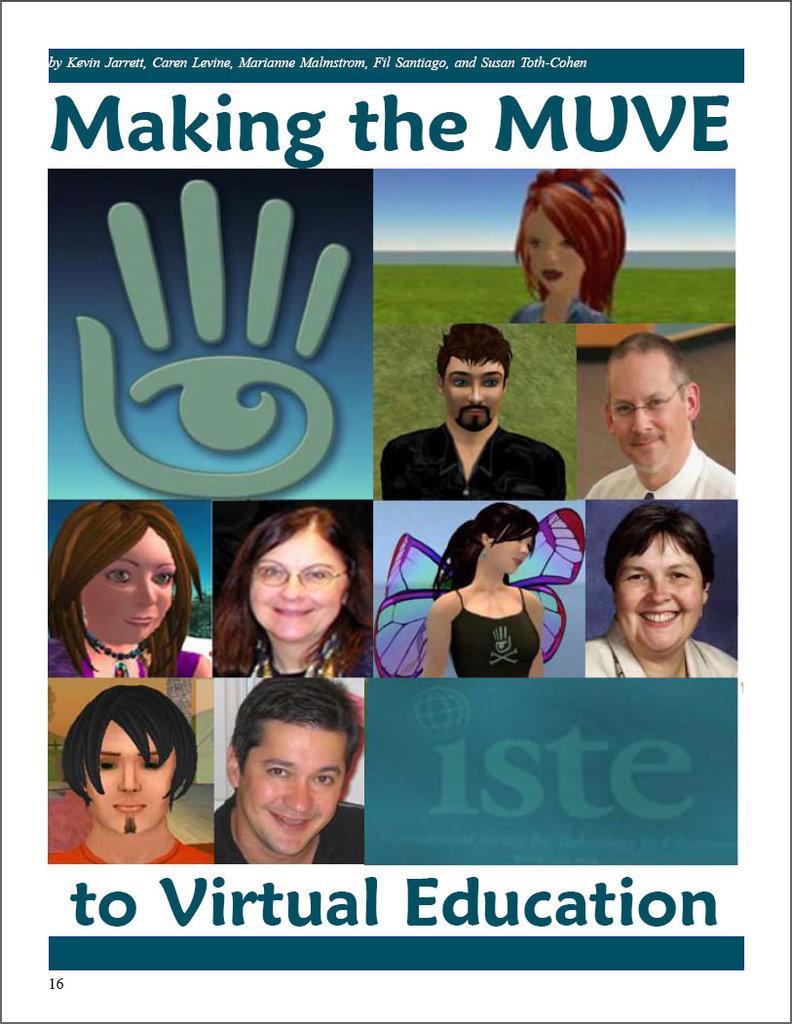Can you describe this image briefly? In this image there is a poster, on that poster there is some text and animated images and four pictures. 